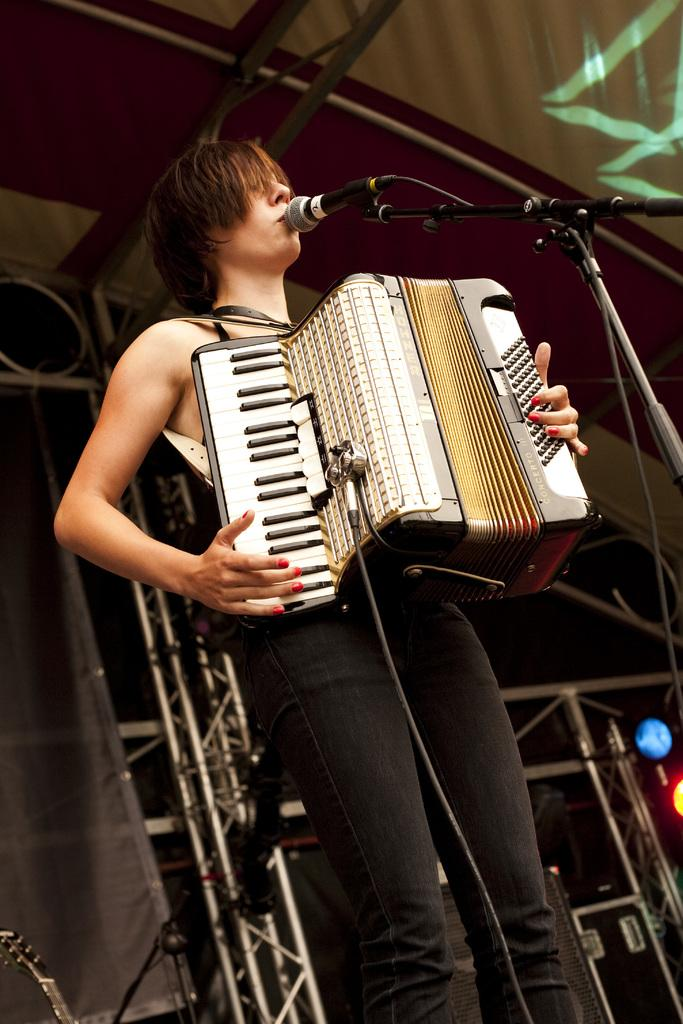Who is in the image? There is a person in the image. What is the person doing in the image? The person is standing near a microphone and playing a musical instrument. What else can be seen in the image? There are cables present in the image. What is visible in the background of the image? There are iron poles in the background of the image. What type of reward is the person receiving for playing the musical instrument in the image? There is no indication in the image that the person is receiving a reward for playing the musical instrument. What other members of the band can be seen in the image? There is no mention of a band or other members in the image; it only shows one person playing a musical instrument. 